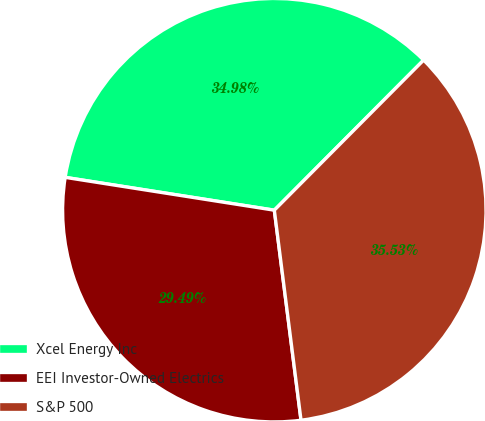Convert chart. <chart><loc_0><loc_0><loc_500><loc_500><pie_chart><fcel>Xcel Energy Inc<fcel>EEI Investor-Owned Electrics<fcel>S&P 500<nl><fcel>34.98%<fcel>29.49%<fcel>35.53%<nl></chart> 